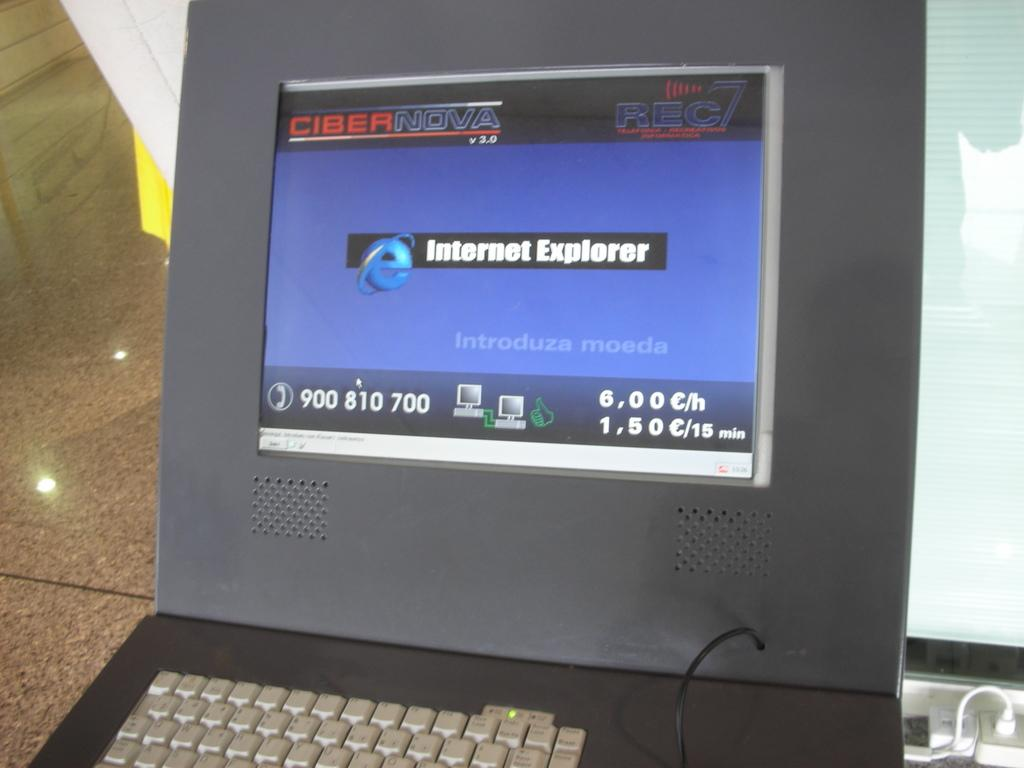<image>
Render a clear and concise summary of the photo. A laptop displays Internet Explorer on the screen. 